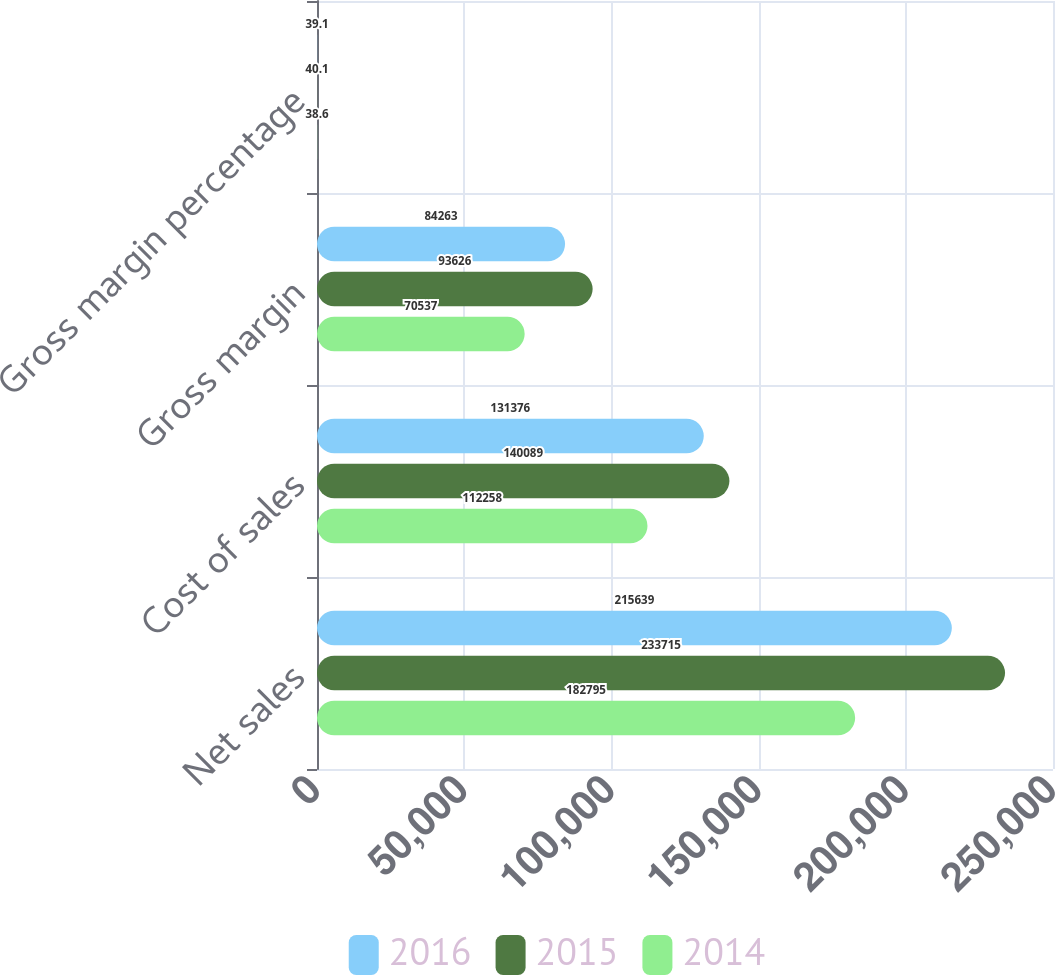Convert chart. <chart><loc_0><loc_0><loc_500><loc_500><stacked_bar_chart><ecel><fcel>Net sales<fcel>Cost of sales<fcel>Gross margin<fcel>Gross margin percentage<nl><fcel>2016<fcel>215639<fcel>131376<fcel>84263<fcel>39.1<nl><fcel>2015<fcel>233715<fcel>140089<fcel>93626<fcel>40.1<nl><fcel>2014<fcel>182795<fcel>112258<fcel>70537<fcel>38.6<nl></chart> 